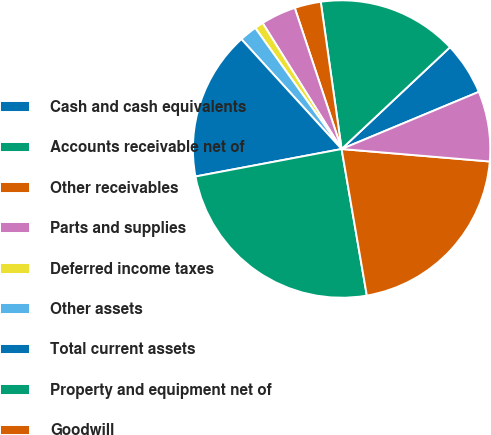<chart> <loc_0><loc_0><loc_500><loc_500><pie_chart><fcel>Cash and cash equivalents<fcel>Accounts receivable net of<fcel>Other receivables<fcel>Parts and supplies<fcel>Deferred income taxes<fcel>Other assets<fcel>Total current assets<fcel>Property and equipment net of<fcel>Goodwill<fcel>Other intangible assets net<nl><fcel>5.72%<fcel>15.24%<fcel>2.86%<fcel>3.81%<fcel>0.95%<fcel>1.91%<fcel>16.19%<fcel>24.76%<fcel>20.95%<fcel>7.62%<nl></chart> 